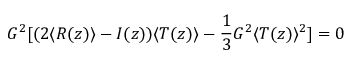<formula> <loc_0><loc_0><loc_500><loc_500>G ^ { 2 } [ ( 2 \langle R ( z ) \rangle - I ( z ) ) \langle T ( z ) \rangle - \frac { 1 } { 3 } G ^ { 2 } \langle T ( z ) \rangle ^ { 2 } ] = 0</formula> 